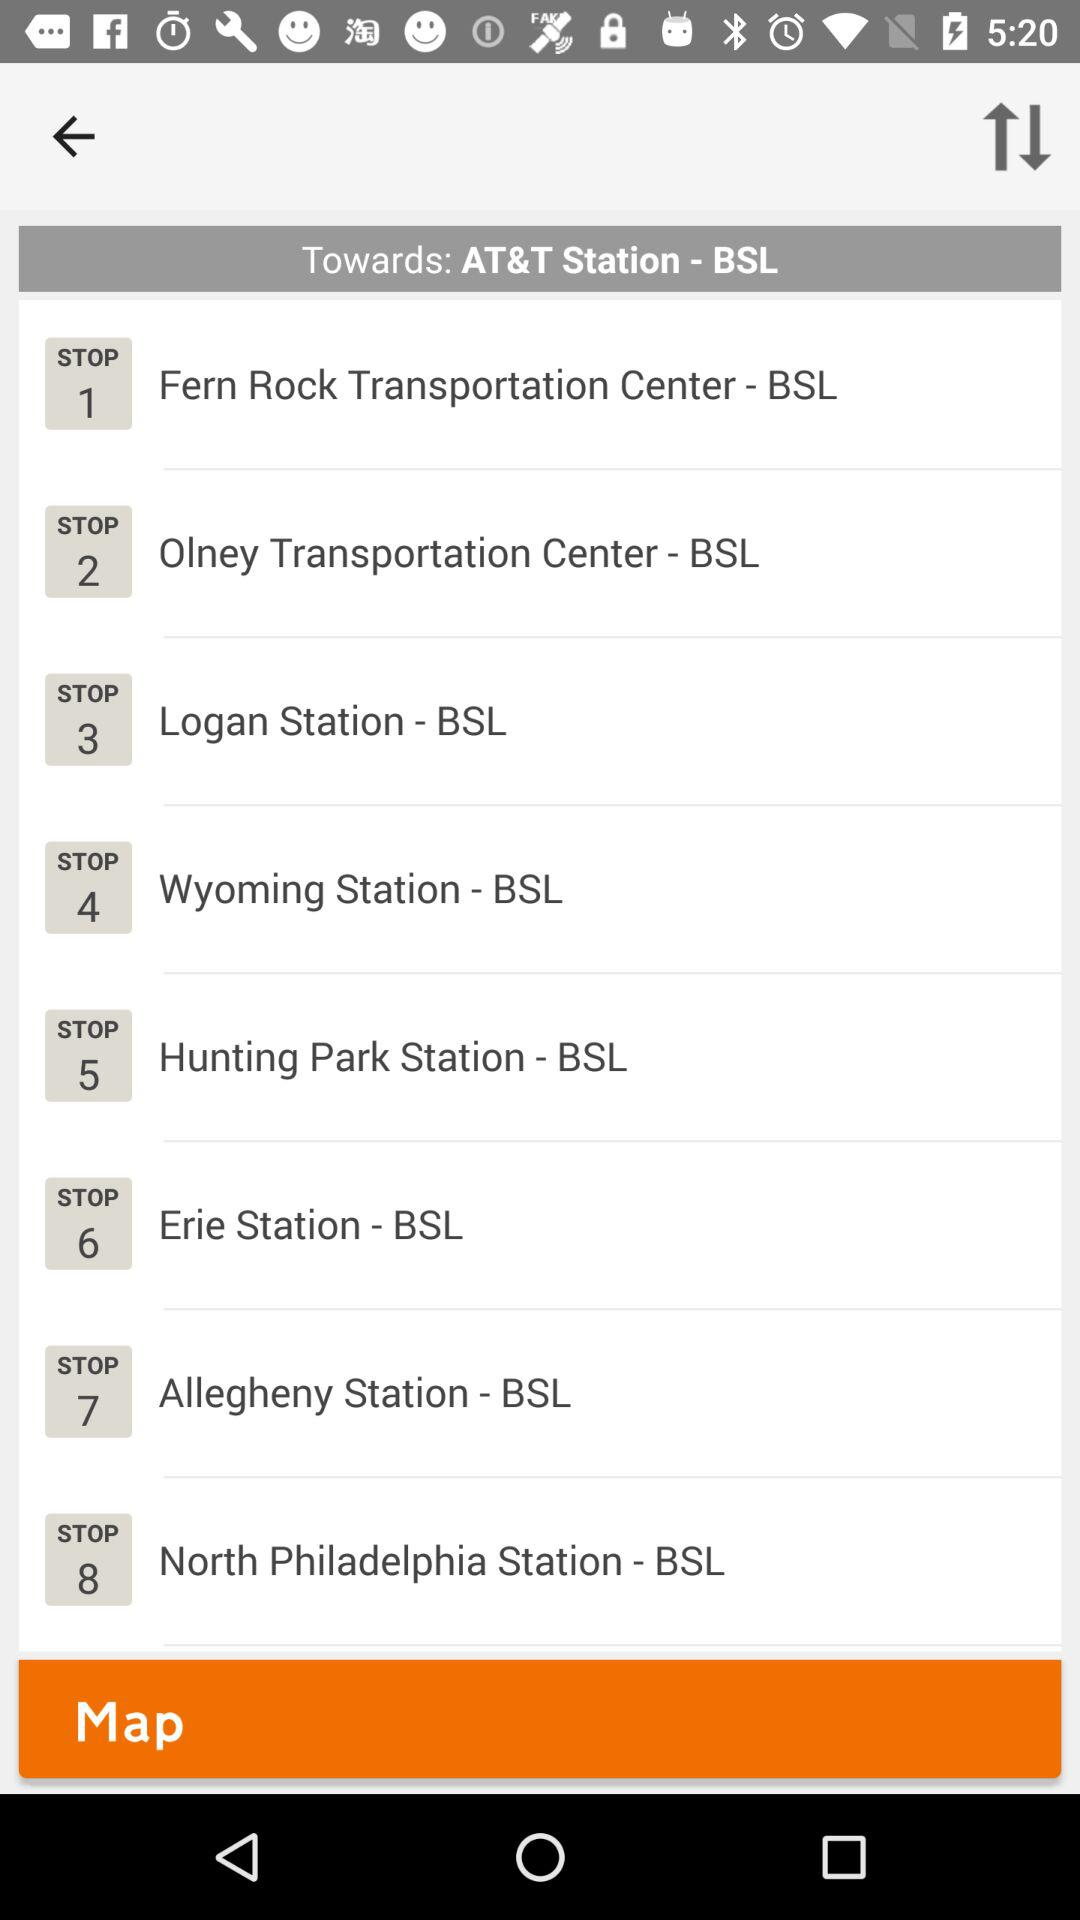What is the final destination of this train route? The final destination of this train route is AT&T Station - BSL, as indicated at the top of the displayed schedule. How many stops are there in total on this route? There are a total of 8 stops on this route towards AT&T Station - BSL. 